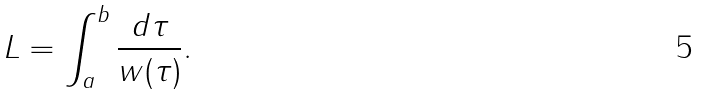<formula> <loc_0><loc_0><loc_500><loc_500>L = \int _ { a } ^ { b } \frac { d \tau } { w ( \tau ) } .</formula> 